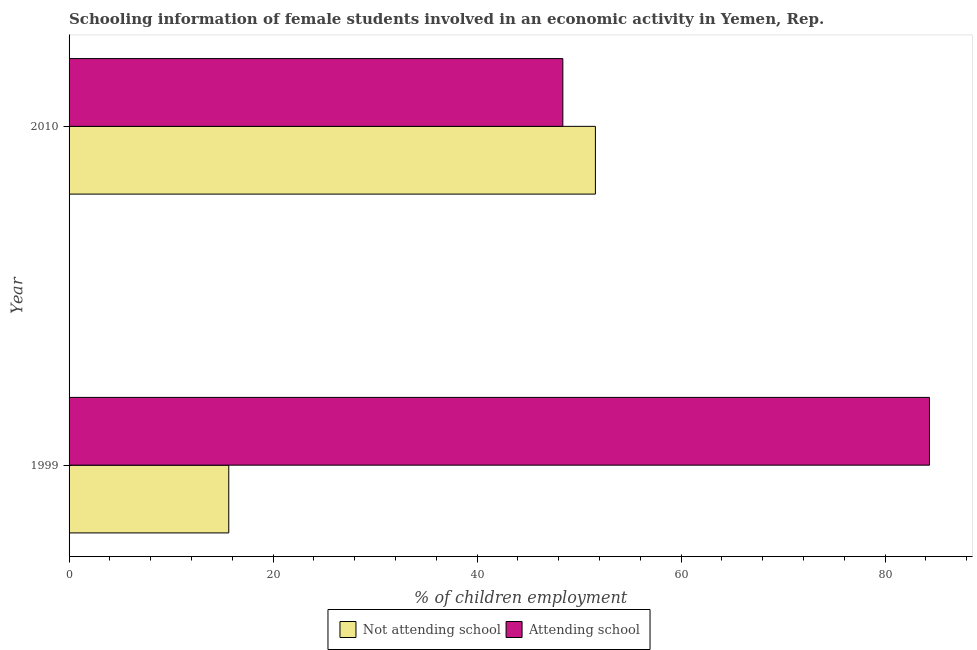How many different coloured bars are there?
Make the answer very short. 2. How many groups of bars are there?
Ensure brevity in your answer.  2. Are the number of bars on each tick of the Y-axis equal?
Your answer should be compact. Yes. What is the label of the 1st group of bars from the top?
Your response must be concise. 2010. What is the percentage of employed females who are attending school in 1999?
Your answer should be compact. 84.34. Across all years, what is the maximum percentage of employed females who are not attending school?
Provide a succinct answer. 51.6. Across all years, what is the minimum percentage of employed females who are not attending school?
Your answer should be very brief. 15.66. In which year was the percentage of employed females who are attending school maximum?
Give a very brief answer. 1999. In which year was the percentage of employed females who are attending school minimum?
Provide a succinct answer. 2010. What is the total percentage of employed females who are not attending school in the graph?
Offer a terse response. 67.25. What is the difference between the percentage of employed females who are attending school in 1999 and that in 2010?
Your answer should be compact. 35.94. What is the difference between the percentage of employed females who are not attending school in 2010 and the percentage of employed females who are attending school in 1999?
Provide a short and direct response. -32.75. What is the average percentage of employed females who are not attending school per year?
Make the answer very short. 33.62. In the year 2010, what is the difference between the percentage of employed females who are attending school and percentage of employed females who are not attending school?
Your answer should be compact. -3.19. What is the ratio of the percentage of employed females who are not attending school in 1999 to that in 2010?
Make the answer very short. 0.3. What does the 1st bar from the top in 2010 represents?
Keep it short and to the point. Attending school. What does the 1st bar from the bottom in 1999 represents?
Your response must be concise. Not attending school. Are all the bars in the graph horizontal?
Offer a very short reply. Yes. How many years are there in the graph?
Offer a terse response. 2. Are the values on the major ticks of X-axis written in scientific E-notation?
Give a very brief answer. No. Does the graph contain any zero values?
Give a very brief answer. No. Does the graph contain grids?
Offer a very short reply. No. How are the legend labels stacked?
Offer a very short reply. Horizontal. What is the title of the graph?
Provide a short and direct response. Schooling information of female students involved in an economic activity in Yemen, Rep. Does "Imports" appear as one of the legend labels in the graph?
Keep it short and to the point. No. What is the label or title of the X-axis?
Give a very brief answer. % of children employment. What is the label or title of the Y-axis?
Keep it short and to the point. Year. What is the % of children employment in Not attending school in 1999?
Your answer should be very brief. 15.66. What is the % of children employment in Attending school in 1999?
Ensure brevity in your answer.  84.34. What is the % of children employment in Not attending school in 2010?
Provide a short and direct response. 51.6. What is the % of children employment in Attending school in 2010?
Your response must be concise. 48.4. Across all years, what is the maximum % of children employment of Not attending school?
Ensure brevity in your answer.  51.6. Across all years, what is the maximum % of children employment in Attending school?
Give a very brief answer. 84.34. Across all years, what is the minimum % of children employment of Not attending school?
Offer a very short reply. 15.66. Across all years, what is the minimum % of children employment in Attending school?
Keep it short and to the point. 48.4. What is the total % of children employment of Not attending school in the graph?
Ensure brevity in your answer.  67.25. What is the total % of children employment of Attending school in the graph?
Give a very brief answer. 132.75. What is the difference between the % of children employment in Not attending school in 1999 and that in 2010?
Make the answer very short. -35.94. What is the difference between the % of children employment of Attending school in 1999 and that in 2010?
Your answer should be very brief. 35.94. What is the difference between the % of children employment of Not attending school in 1999 and the % of children employment of Attending school in 2010?
Give a very brief answer. -32.75. What is the average % of children employment in Not attending school per year?
Ensure brevity in your answer.  33.63. What is the average % of children employment of Attending school per year?
Give a very brief answer. 66.37. In the year 1999, what is the difference between the % of children employment of Not attending school and % of children employment of Attending school?
Offer a terse response. -68.69. In the year 2010, what is the difference between the % of children employment in Not attending school and % of children employment in Attending school?
Ensure brevity in your answer.  3.19. What is the ratio of the % of children employment of Not attending school in 1999 to that in 2010?
Your answer should be compact. 0.3. What is the ratio of the % of children employment in Attending school in 1999 to that in 2010?
Make the answer very short. 1.74. What is the difference between the highest and the second highest % of children employment of Not attending school?
Give a very brief answer. 35.94. What is the difference between the highest and the second highest % of children employment of Attending school?
Provide a succinct answer. 35.94. What is the difference between the highest and the lowest % of children employment in Not attending school?
Provide a short and direct response. 35.94. What is the difference between the highest and the lowest % of children employment of Attending school?
Your answer should be very brief. 35.94. 